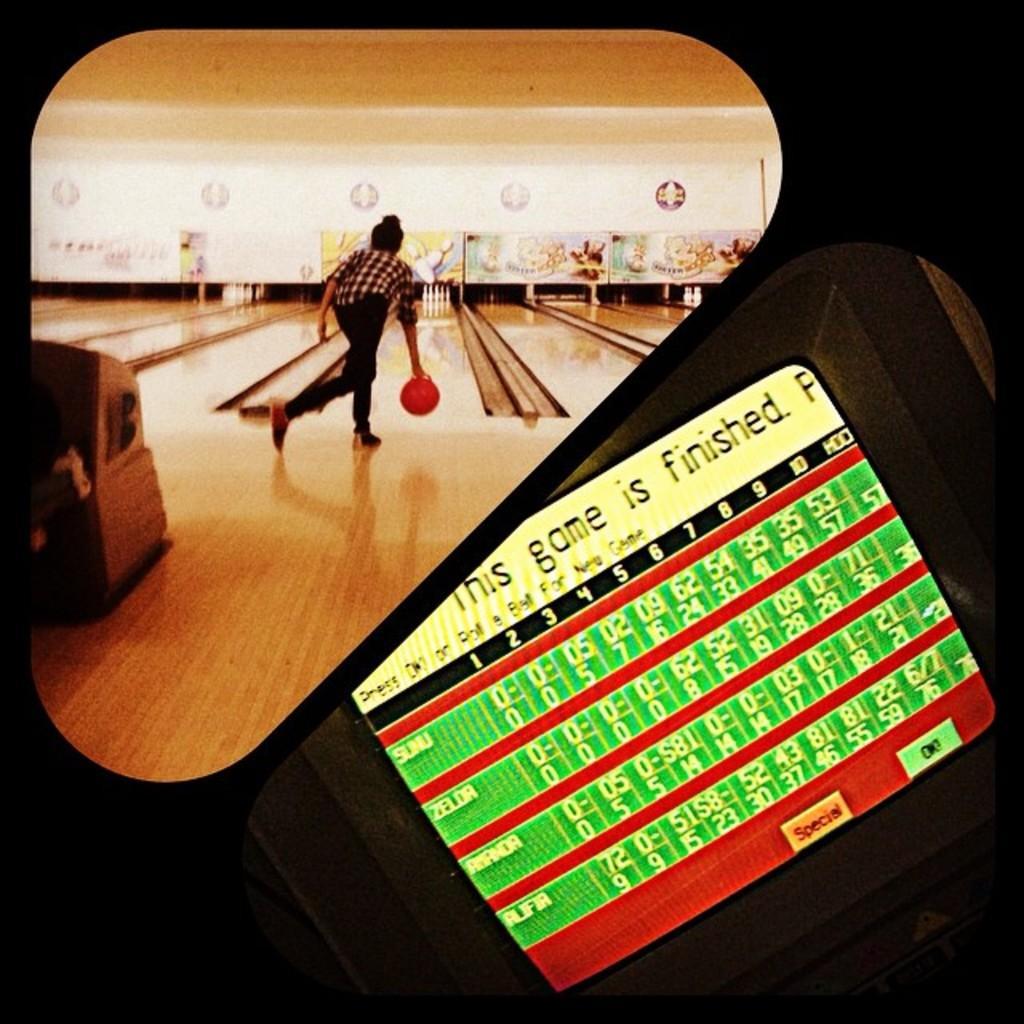How would you summarize this image in a sentence or two? In the picture I can see a person is holding a ball in the hand. In the background I can see bowling pins and some other things. I can also see something written on the image. 